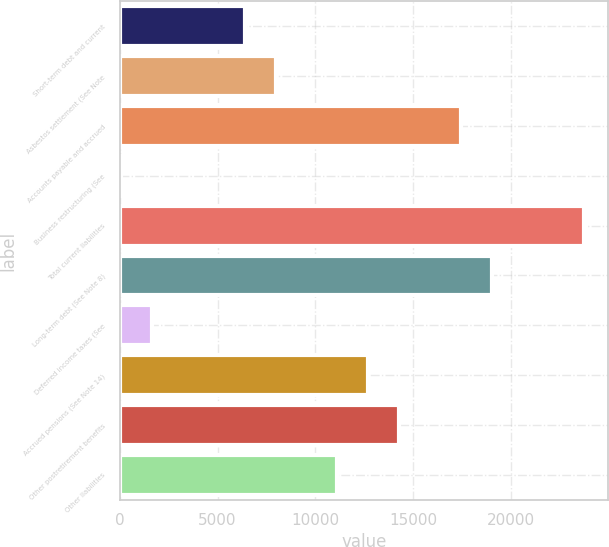Convert chart. <chart><loc_0><loc_0><loc_500><loc_500><bar_chart><fcel>Short-term debt and current<fcel>Asbestos settlement (See Note<fcel>Accounts payable and accrued<fcel>Business restructuring (See<fcel>Total current liabilities<fcel>Long-term debt (See Note 8)<fcel>Deferred income taxes (See<fcel>Accrued pensions (See Note 14)<fcel>Other postretirement benefits<fcel>Other liabilities<nl><fcel>6396.2<fcel>7976.5<fcel>17458.3<fcel>75<fcel>23779.5<fcel>19038.6<fcel>1655.3<fcel>12717.4<fcel>14297.7<fcel>11137.1<nl></chart> 